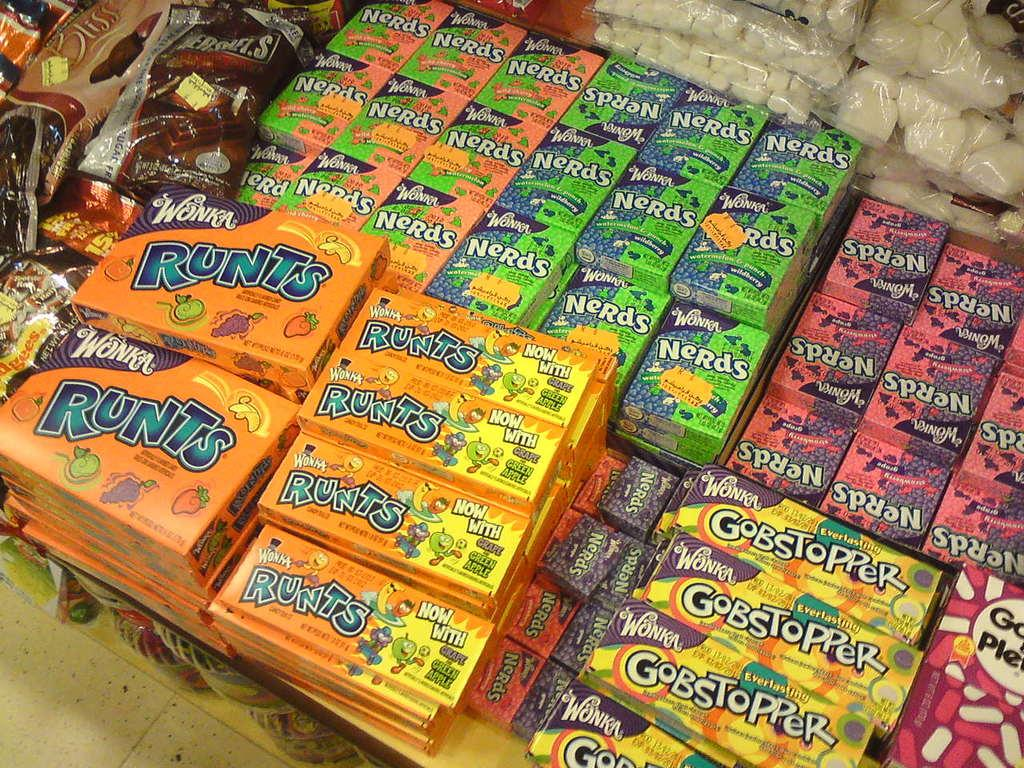What type of sweets can be seen in the image? There are candies and toffees in the image. Can you describe any other items visible in the image? There are other items in the image, but their specific nature is not mentioned in the provided facts. Where is the deer located in the image? There is no deer present in the image. What type of lock is used on the bedroom door in the image? There is no bedroom or lock present in the image. 